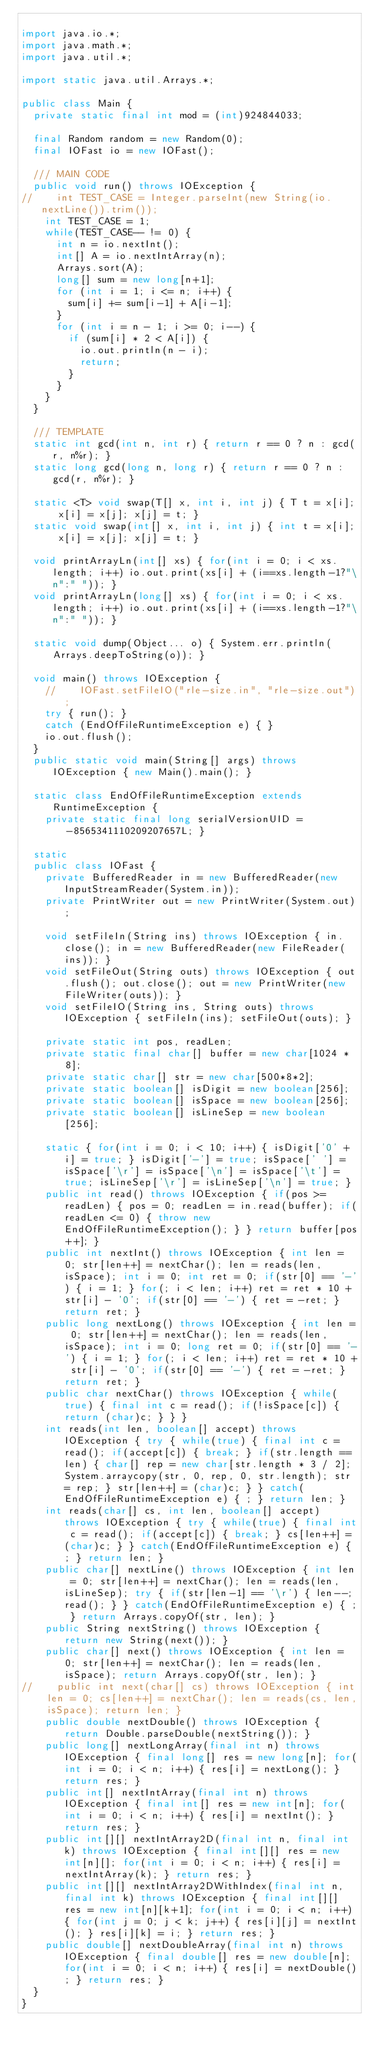<code> <loc_0><loc_0><loc_500><loc_500><_Java_>
import java.io.*;
import java.math.*;
import java.util.*;

import static java.util.Arrays.*;

public class Main {
	private static final int mod = (int)924844033;

	final Random random = new Random(0);
	final IOFast io = new IOFast();

	/// MAIN CODE
	public void run() throws IOException {
//		int TEST_CASE = Integer.parseInt(new String(io.nextLine()).trim());
		int TEST_CASE = 1;
		while(TEST_CASE-- != 0) {
			int n = io.nextInt();
			int[] A = io.nextIntArray(n);
			Arrays.sort(A);
			long[] sum = new long[n+1];
			for (int i = 1; i <= n; i++) {
				sum[i] += sum[i-1] + A[i-1];
			}
			for (int i = n - 1; i >= 0; i--) {
				if (sum[i] * 2 < A[i]) {
					io.out.println(n - i);
					return;
				}
			}
		}
	}
	
	/// TEMPLATE
	static int gcd(int n, int r) { return r == 0 ? n : gcd(r, n%r); }
	static long gcd(long n, long r) { return r == 0 ? n : gcd(r, n%r); }
	
	static <T> void swap(T[] x, int i, int j) { T t = x[i]; x[i] = x[j]; x[j] = t; }
	static void swap(int[] x, int i, int j) { int t = x[i]; x[i] = x[j]; x[j] = t; }

	void printArrayLn(int[] xs) { for(int i = 0; i < xs.length; i++) io.out.print(xs[i] + (i==xs.length-1?"\n":" ")); }
	void printArrayLn(long[] xs) { for(int i = 0; i < xs.length; i++) io.out.print(xs[i] + (i==xs.length-1?"\n":" ")); }
	
	static void dump(Object... o) { System.err.println(Arrays.deepToString(o)); } 
	
	void main() throws IOException {
		//		IOFast.setFileIO("rle-size.in", "rle-size.out");
		try { run(); }
		catch (EndOfFileRuntimeException e) { }
		io.out.flush();
	}
	public static void main(String[] args) throws IOException { new Main().main(); }
	
	static class EndOfFileRuntimeException extends RuntimeException {
		private static final long serialVersionUID = -8565341110209207657L; }

	static
	public class IOFast {
		private BufferedReader in = new BufferedReader(new InputStreamReader(System.in));
		private PrintWriter out = new PrintWriter(System.out);

		void setFileIn(String ins) throws IOException { in.close(); in = new BufferedReader(new FileReader(ins)); }
		void setFileOut(String outs) throws IOException { out.flush(); out.close(); out = new PrintWriter(new FileWriter(outs)); }
		void setFileIO(String ins, String outs) throws IOException { setFileIn(ins); setFileOut(outs); }

		private static int pos, readLen;
		private static final char[] buffer = new char[1024 * 8];
		private static char[] str = new char[500*8*2];
		private static boolean[] isDigit = new boolean[256];
		private static boolean[] isSpace = new boolean[256];
		private static boolean[] isLineSep = new boolean[256];

		static { for(int i = 0; i < 10; i++) { isDigit['0' + i] = true; } isDigit['-'] = true; isSpace[' '] = isSpace['\r'] = isSpace['\n'] = isSpace['\t'] = true; isLineSep['\r'] = isLineSep['\n'] = true; }
		public int read() throws IOException { if(pos >= readLen) { pos = 0; readLen = in.read(buffer); if(readLen <= 0) { throw new EndOfFileRuntimeException(); } } return buffer[pos++]; }
		public int nextInt() throws IOException { int len = 0; str[len++] = nextChar(); len = reads(len, isSpace); int i = 0; int ret = 0; if(str[0] == '-') { i = 1; } for(; i < len; i++) ret = ret * 10 + str[i] - '0'; if(str[0] == '-') { ret = -ret; } return ret; }
		public long nextLong() throws IOException { int len = 0; str[len++] = nextChar(); len = reads(len, isSpace); int i = 0; long ret = 0; if(str[0] == '-') { i = 1; } for(; i < len; i++) ret = ret * 10 + str[i] - '0'; if(str[0] == '-') { ret = -ret; } return ret; }
		public char nextChar() throws IOException { while(true) { final int c = read(); if(!isSpace[c]) { return (char)c; } } }
		int reads(int len, boolean[] accept) throws IOException { try { while(true) { final int c = read(); if(accept[c]) { break; } if(str.length == len) { char[] rep = new char[str.length * 3 / 2]; System.arraycopy(str, 0, rep, 0, str.length); str = rep; } str[len++] = (char)c; } } catch(EndOfFileRuntimeException e) { ; } return len; }
		int reads(char[] cs, int len, boolean[] accept) throws IOException { try { while(true) { final int c = read(); if(accept[c]) { break; } cs[len++] = (char)c; } } catch(EndOfFileRuntimeException e) { ; } return len; }
		public char[] nextLine() throws IOException { int len = 0; str[len++] = nextChar(); len = reads(len, isLineSep); try { if(str[len-1] == '\r') { len--; read(); } } catch(EndOfFileRuntimeException e) { ; } return Arrays.copyOf(str, len); }
		public String nextString() throws IOException { return new String(next()); }
		public char[] next() throws IOException { int len = 0; str[len++] = nextChar(); len = reads(len, isSpace); return Arrays.copyOf(str, len); }
//		public int next(char[] cs) throws IOException { int len = 0; cs[len++] = nextChar(); len = reads(cs, len, isSpace); return len; }
		public double nextDouble() throws IOException { return Double.parseDouble(nextString()); }
		public long[] nextLongArray(final int n) throws IOException { final long[] res = new long[n]; for(int i = 0; i < n; i++) { res[i] = nextLong(); } return res; }
		public int[] nextIntArray(final int n) throws IOException { final int[] res = new int[n]; for(int i = 0; i < n; i++) { res[i] = nextInt(); } return res; }
		public int[][] nextIntArray2D(final int n, final int k) throws IOException { final int[][] res = new int[n][]; for(int i = 0; i < n; i++) { res[i] = nextIntArray(k); } return res; }
		public int[][] nextIntArray2DWithIndex(final int n, final int k) throws IOException { final int[][] res = new int[n][k+1]; for(int i = 0; i < n; i++) { for(int j = 0; j < k; j++) { res[i][j] = nextInt(); } res[i][k] = i; } return res; }
		public double[] nextDoubleArray(final int n) throws IOException { final double[] res = new double[n]; for(int i = 0; i < n; i++) { res[i] = nextDouble(); } return res; }
	}
}
</code> 